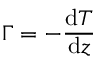<formula> <loc_0><loc_0><loc_500><loc_500>\Gamma = - { \frac { d T } { d z } }</formula> 